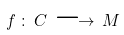Convert formula to latex. <formula><loc_0><loc_0><loc_500><loc_500>f \, \colon \, C \, \longrightarrow \, M</formula> 